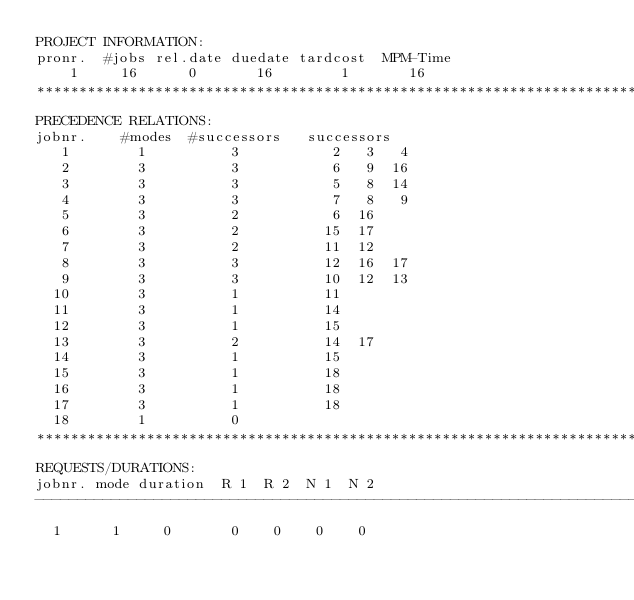Convert code to text. <code><loc_0><loc_0><loc_500><loc_500><_ObjectiveC_>PROJECT INFORMATION:
pronr.  #jobs rel.date duedate tardcost  MPM-Time
    1     16      0       16        1       16
************************************************************************
PRECEDENCE RELATIONS:
jobnr.    #modes  #successors   successors
   1        1          3           2   3   4
   2        3          3           6   9  16
   3        3          3           5   8  14
   4        3          3           7   8   9
   5        3          2           6  16
   6        3          2          15  17
   7        3          2          11  12
   8        3          3          12  16  17
   9        3          3          10  12  13
  10        3          1          11
  11        3          1          14
  12        3          1          15
  13        3          2          14  17
  14        3          1          15
  15        3          1          18
  16        3          1          18
  17        3          1          18
  18        1          0        
************************************************************************
REQUESTS/DURATIONS:
jobnr. mode duration  R 1  R 2  N 1  N 2
------------------------------------------------------------------------
  1      1     0       0    0    0    0</code> 